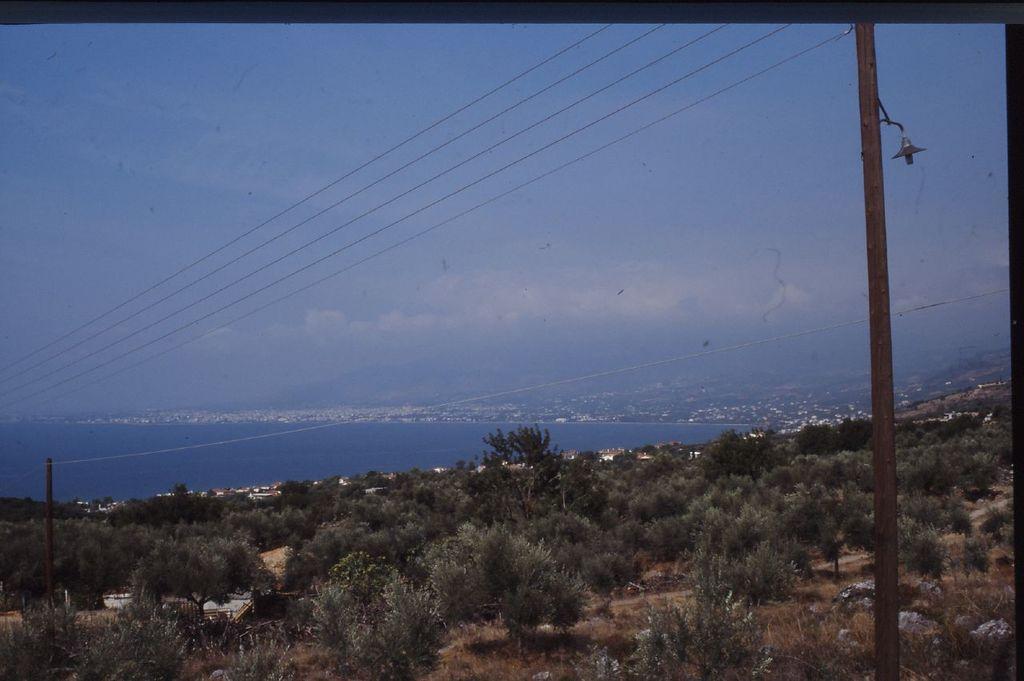Could you give a brief overview of what you see in this image? In this image we can see trees, pole, wires and a sea. The sky is in blue with some clouds. 